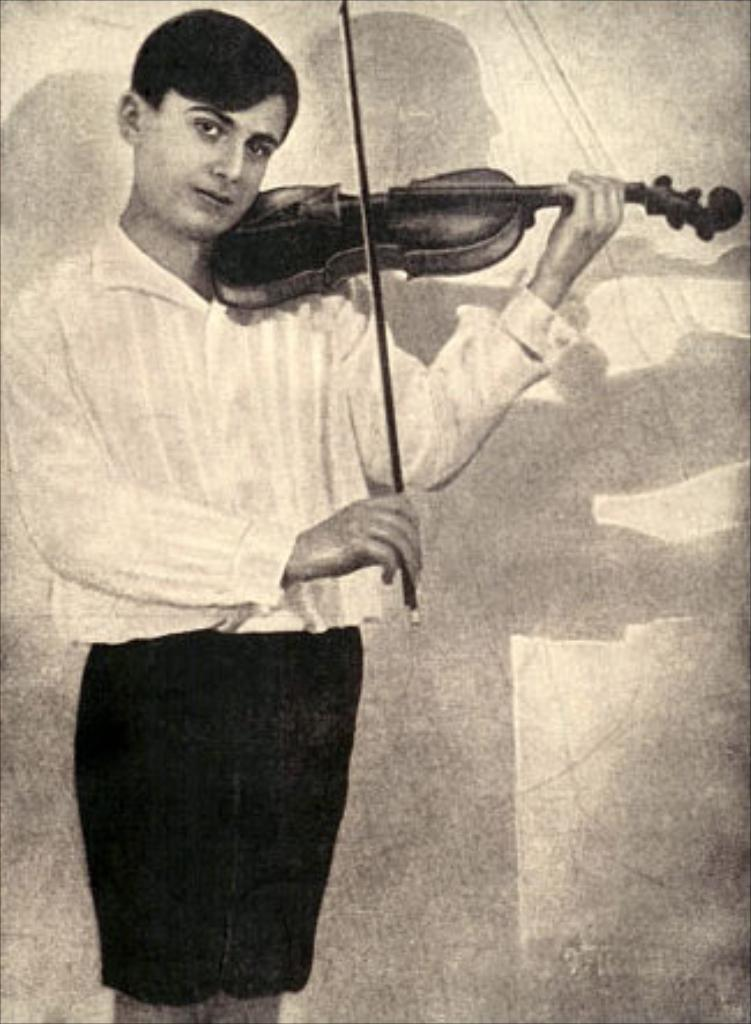What is the person in the image doing? The person is playing a guitar. How is the person positioned in the image? The person is standing. What can be seen in the background of the image? There is a white color wall and a shadow in the background. What type of operation is being performed on the guitar in the image? There is no operation being performed on the guitar in the image; the person is simply playing it. 